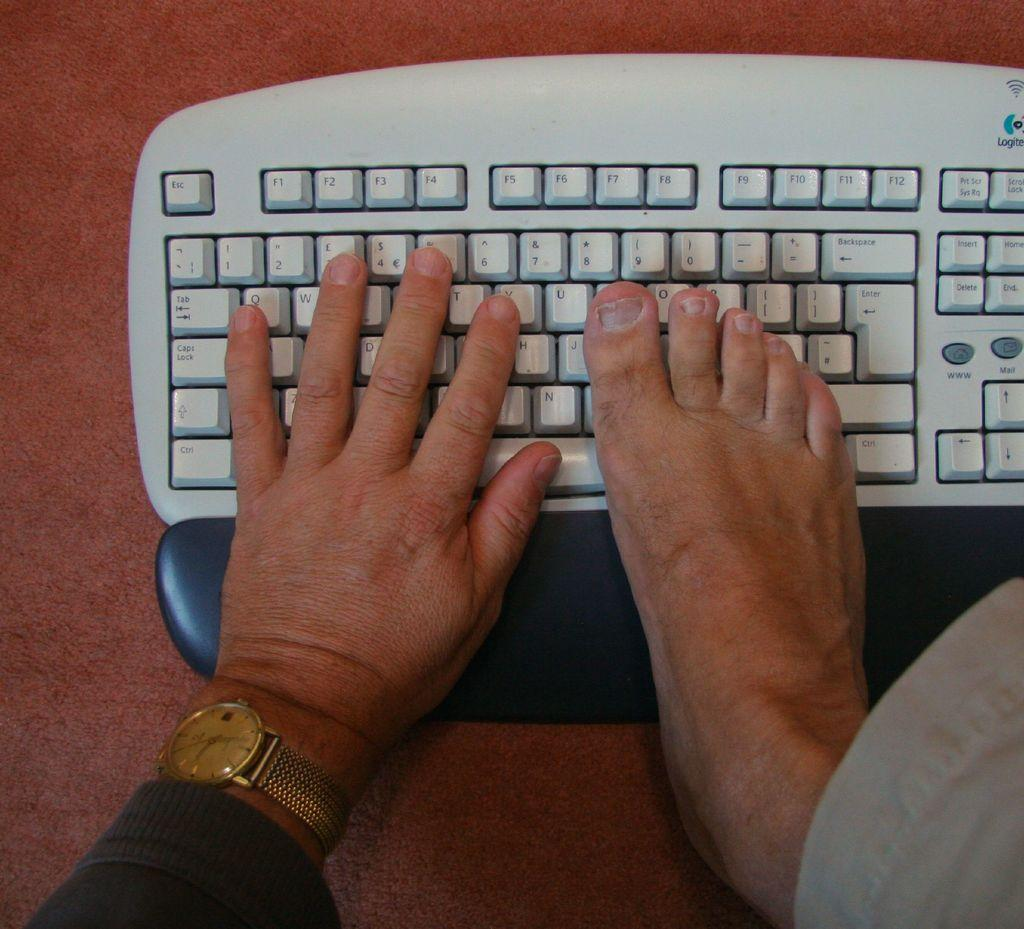Provide a one-sentence caption for the provided image. Person typing on the keyboard with the ESC key on the top left. 